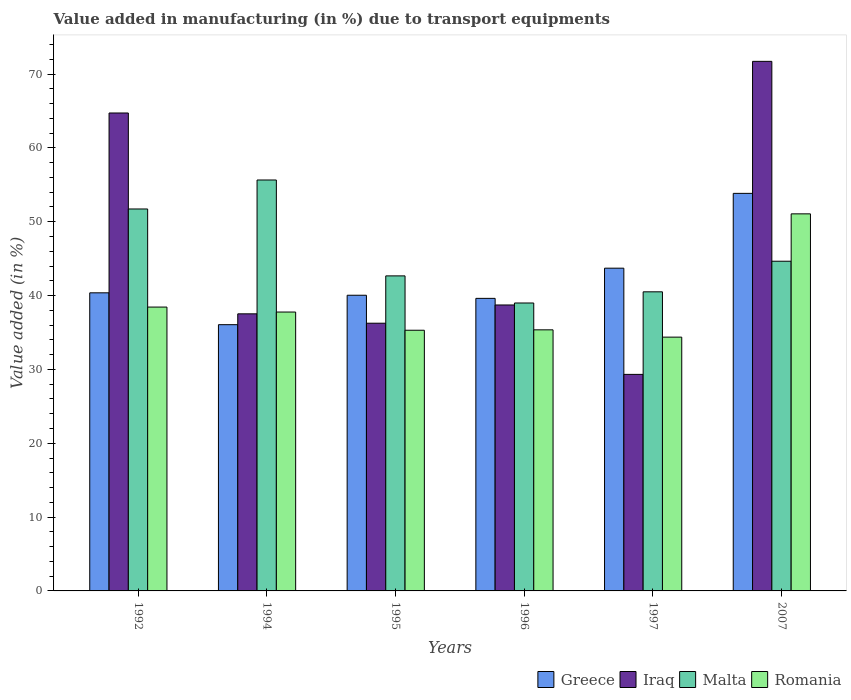How many different coloured bars are there?
Make the answer very short. 4. Are the number of bars per tick equal to the number of legend labels?
Make the answer very short. Yes. Are the number of bars on each tick of the X-axis equal?
Give a very brief answer. Yes. How many bars are there on the 6th tick from the right?
Your answer should be very brief. 4. What is the label of the 6th group of bars from the left?
Offer a very short reply. 2007. In how many cases, is the number of bars for a given year not equal to the number of legend labels?
Provide a succinct answer. 0. What is the percentage of value added in manufacturing due to transport equipments in Greece in 2007?
Offer a terse response. 53.84. Across all years, what is the maximum percentage of value added in manufacturing due to transport equipments in Romania?
Offer a very short reply. 51.06. Across all years, what is the minimum percentage of value added in manufacturing due to transport equipments in Romania?
Your answer should be compact. 34.37. In which year was the percentage of value added in manufacturing due to transport equipments in Romania maximum?
Offer a terse response. 2007. In which year was the percentage of value added in manufacturing due to transport equipments in Iraq minimum?
Offer a terse response. 1997. What is the total percentage of value added in manufacturing due to transport equipments in Malta in the graph?
Provide a succinct answer. 274.17. What is the difference between the percentage of value added in manufacturing due to transport equipments in Greece in 1995 and that in 1997?
Your answer should be very brief. -3.67. What is the difference between the percentage of value added in manufacturing due to transport equipments in Iraq in 2007 and the percentage of value added in manufacturing due to transport equipments in Malta in 1994?
Provide a succinct answer. 16.07. What is the average percentage of value added in manufacturing due to transport equipments in Romania per year?
Your response must be concise. 38.71. In the year 1995, what is the difference between the percentage of value added in manufacturing due to transport equipments in Romania and percentage of value added in manufacturing due to transport equipments in Iraq?
Your answer should be very brief. -0.95. In how many years, is the percentage of value added in manufacturing due to transport equipments in Malta greater than 46 %?
Your answer should be compact. 2. What is the ratio of the percentage of value added in manufacturing due to transport equipments in Iraq in 1992 to that in 2007?
Provide a short and direct response. 0.9. Is the percentage of value added in manufacturing due to transport equipments in Iraq in 1996 less than that in 2007?
Your answer should be compact. Yes. What is the difference between the highest and the second highest percentage of value added in manufacturing due to transport equipments in Iraq?
Provide a succinct answer. 6.99. What is the difference between the highest and the lowest percentage of value added in manufacturing due to transport equipments in Greece?
Offer a terse response. 17.78. In how many years, is the percentage of value added in manufacturing due to transport equipments in Romania greater than the average percentage of value added in manufacturing due to transport equipments in Romania taken over all years?
Give a very brief answer. 1. Is the sum of the percentage of value added in manufacturing due to transport equipments in Romania in 1996 and 1997 greater than the maximum percentage of value added in manufacturing due to transport equipments in Greece across all years?
Keep it short and to the point. Yes. What does the 1st bar from the left in 1994 represents?
Your answer should be very brief. Greece. What does the 2nd bar from the right in 1995 represents?
Offer a very short reply. Malta. Is it the case that in every year, the sum of the percentage of value added in manufacturing due to transport equipments in Romania and percentage of value added in manufacturing due to transport equipments in Greece is greater than the percentage of value added in manufacturing due to transport equipments in Iraq?
Keep it short and to the point. Yes. How many years are there in the graph?
Keep it short and to the point. 6. What is the difference between two consecutive major ticks on the Y-axis?
Keep it short and to the point. 10. Does the graph contain grids?
Offer a terse response. No. Where does the legend appear in the graph?
Make the answer very short. Bottom right. What is the title of the graph?
Provide a succinct answer. Value added in manufacturing (in %) due to transport equipments. Does "Grenada" appear as one of the legend labels in the graph?
Your answer should be compact. No. What is the label or title of the X-axis?
Provide a succinct answer. Years. What is the label or title of the Y-axis?
Offer a terse response. Value added (in %). What is the Value added (in %) of Greece in 1992?
Provide a short and direct response. 40.37. What is the Value added (in %) in Iraq in 1992?
Keep it short and to the point. 64.72. What is the Value added (in %) in Malta in 1992?
Your answer should be compact. 51.72. What is the Value added (in %) of Romania in 1992?
Make the answer very short. 38.44. What is the Value added (in %) of Greece in 1994?
Ensure brevity in your answer.  36.05. What is the Value added (in %) in Iraq in 1994?
Make the answer very short. 37.52. What is the Value added (in %) in Malta in 1994?
Ensure brevity in your answer.  55.65. What is the Value added (in %) of Romania in 1994?
Provide a short and direct response. 37.77. What is the Value added (in %) of Greece in 1995?
Ensure brevity in your answer.  40.04. What is the Value added (in %) in Iraq in 1995?
Make the answer very short. 36.25. What is the Value added (in %) of Malta in 1995?
Offer a terse response. 42.66. What is the Value added (in %) of Romania in 1995?
Your answer should be compact. 35.3. What is the Value added (in %) in Greece in 1996?
Provide a succinct answer. 39.62. What is the Value added (in %) in Iraq in 1996?
Offer a very short reply. 38.72. What is the Value added (in %) in Malta in 1996?
Your answer should be compact. 38.99. What is the Value added (in %) in Romania in 1996?
Give a very brief answer. 35.36. What is the Value added (in %) in Greece in 1997?
Your answer should be compact. 43.71. What is the Value added (in %) of Iraq in 1997?
Keep it short and to the point. 29.32. What is the Value added (in %) of Malta in 1997?
Provide a succinct answer. 40.5. What is the Value added (in %) in Romania in 1997?
Your answer should be very brief. 34.37. What is the Value added (in %) in Greece in 2007?
Offer a very short reply. 53.84. What is the Value added (in %) of Iraq in 2007?
Your answer should be compact. 71.71. What is the Value added (in %) of Malta in 2007?
Offer a very short reply. 44.65. What is the Value added (in %) in Romania in 2007?
Make the answer very short. 51.06. Across all years, what is the maximum Value added (in %) of Greece?
Provide a short and direct response. 53.84. Across all years, what is the maximum Value added (in %) in Iraq?
Provide a short and direct response. 71.71. Across all years, what is the maximum Value added (in %) of Malta?
Your answer should be compact. 55.65. Across all years, what is the maximum Value added (in %) of Romania?
Keep it short and to the point. 51.06. Across all years, what is the minimum Value added (in %) of Greece?
Ensure brevity in your answer.  36.05. Across all years, what is the minimum Value added (in %) of Iraq?
Provide a short and direct response. 29.32. Across all years, what is the minimum Value added (in %) of Malta?
Your answer should be compact. 38.99. Across all years, what is the minimum Value added (in %) of Romania?
Offer a terse response. 34.37. What is the total Value added (in %) of Greece in the graph?
Your answer should be very brief. 253.62. What is the total Value added (in %) of Iraq in the graph?
Offer a terse response. 278.26. What is the total Value added (in %) in Malta in the graph?
Make the answer very short. 274.17. What is the total Value added (in %) in Romania in the graph?
Provide a succinct answer. 232.29. What is the difference between the Value added (in %) in Greece in 1992 and that in 1994?
Offer a terse response. 4.31. What is the difference between the Value added (in %) in Iraq in 1992 and that in 1994?
Offer a terse response. 27.2. What is the difference between the Value added (in %) in Malta in 1992 and that in 1994?
Your response must be concise. -3.92. What is the difference between the Value added (in %) of Romania in 1992 and that in 1994?
Keep it short and to the point. 0.67. What is the difference between the Value added (in %) of Greece in 1992 and that in 1995?
Offer a very short reply. 0.33. What is the difference between the Value added (in %) of Iraq in 1992 and that in 1995?
Your answer should be very brief. 28.47. What is the difference between the Value added (in %) of Malta in 1992 and that in 1995?
Ensure brevity in your answer.  9.06. What is the difference between the Value added (in %) in Romania in 1992 and that in 1995?
Keep it short and to the point. 3.14. What is the difference between the Value added (in %) of Greece in 1992 and that in 1996?
Your answer should be very brief. 0.75. What is the difference between the Value added (in %) of Iraq in 1992 and that in 1996?
Give a very brief answer. 26. What is the difference between the Value added (in %) of Malta in 1992 and that in 1996?
Offer a very short reply. 12.73. What is the difference between the Value added (in %) of Romania in 1992 and that in 1996?
Keep it short and to the point. 3.08. What is the difference between the Value added (in %) in Greece in 1992 and that in 1997?
Provide a short and direct response. -3.34. What is the difference between the Value added (in %) of Iraq in 1992 and that in 1997?
Offer a terse response. 35.4. What is the difference between the Value added (in %) in Malta in 1992 and that in 1997?
Your answer should be very brief. 11.22. What is the difference between the Value added (in %) of Romania in 1992 and that in 1997?
Your response must be concise. 4.07. What is the difference between the Value added (in %) in Greece in 1992 and that in 2007?
Keep it short and to the point. -13.47. What is the difference between the Value added (in %) in Iraq in 1992 and that in 2007?
Your response must be concise. -6.99. What is the difference between the Value added (in %) in Malta in 1992 and that in 2007?
Keep it short and to the point. 7.07. What is the difference between the Value added (in %) of Romania in 1992 and that in 2007?
Keep it short and to the point. -12.62. What is the difference between the Value added (in %) of Greece in 1994 and that in 1995?
Keep it short and to the point. -3.99. What is the difference between the Value added (in %) in Iraq in 1994 and that in 1995?
Provide a succinct answer. 1.27. What is the difference between the Value added (in %) of Malta in 1994 and that in 1995?
Your answer should be compact. 12.98. What is the difference between the Value added (in %) in Romania in 1994 and that in 1995?
Offer a terse response. 2.46. What is the difference between the Value added (in %) of Greece in 1994 and that in 1996?
Your response must be concise. -3.56. What is the difference between the Value added (in %) in Iraq in 1994 and that in 1996?
Make the answer very short. -1.2. What is the difference between the Value added (in %) in Malta in 1994 and that in 1996?
Provide a succinct answer. 16.66. What is the difference between the Value added (in %) in Romania in 1994 and that in 1996?
Ensure brevity in your answer.  2.41. What is the difference between the Value added (in %) of Greece in 1994 and that in 1997?
Provide a short and direct response. -7.65. What is the difference between the Value added (in %) in Iraq in 1994 and that in 1997?
Offer a terse response. 8.2. What is the difference between the Value added (in %) in Malta in 1994 and that in 1997?
Offer a very short reply. 15.14. What is the difference between the Value added (in %) in Romania in 1994 and that in 1997?
Provide a succinct answer. 3.4. What is the difference between the Value added (in %) of Greece in 1994 and that in 2007?
Your answer should be very brief. -17.78. What is the difference between the Value added (in %) of Iraq in 1994 and that in 2007?
Provide a short and direct response. -34.19. What is the difference between the Value added (in %) of Malta in 1994 and that in 2007?
Your answer should be compact. 11. What is the difference between the Value added (in %) in Romania in 1994 and that in 2007?
Offer a terse response. -13.3. What is the difference between the Value added (in %) of Greece in 1995 and that in 1996?
Ensure brevity in your answer.  0.42. What is the difference between the Value added (in %) in Iraq in 1995 and that in 1996?
Offer a terse response. -2.47. What is the difference between the Value added (in %) of Malta in 1995 and that in 1996?
Keep it short and to the point. 3.67. What is the difference between the Value added (in %) of Romania in 1995 and that in 1996?
Offer a terse response. -0.06. What is the difference between the Value added (in %) of Greece in 1995 and that in 1997?
Offer a very short reply. -3.67. What is the difference between the Value added (in %) in Iraq in 1995 and that in 1997?
Ensure brevity in your answer.  6.93. What is the difference between the Value added (in %) in Malta in 1995 and that in 1997?
Give a very brief answer. 2.16. What is the difference between the Value added (in %) of Romania in 1995 and that in 1997?
Keep it short and to the point. 0.93. What is the difference between the Value added (in %) in Greece in 1995 and that in 2007?
Offer a very short reply. -13.8. What is the difference between the Value added (in %) in Iraq in 1995 and that in 2007?
Keep it short and to the point. -35.46. What is the difference between the Value added (in %) in Malta in 1995 and that in 2007?
Provide a short and direct response. -1.99. What is the difference between the Value added (in %) of Romania in 1995 and that in 2007?
Your answer should be compact. -15.76. What is the difference between the Value added (in %) in Greece in 1996 and that in 1997?
Ensure brevity in your answer.  -4.09. What is the difference between the Value added (in %) of Iraq in 1996 and that in 1997?
Provide a succinct answer. 9.4. What is the difference between the Value added (in %) of Malta in 1996 and that in 1997?
Provide a short and direct response. -1.51. What is the difference between the Value added (in %) of Greece in 1996 and that in 2007?
Offer a terse response. -14.22. What is the difference between the Value added (in %) of Iraq in 1996 and that in 2007?
Make the answer very short. -32.99. What is the difference between the Value added (in %) of Malta in 1996 and that in 2007?
Keep it short and to the point. -5.66. What is the difference between the Value added (in %) of Romania in 1996 and that in 2007?
Your answer should be compact. -15.71. What is the difference between the Value added (in %) of Greece in 1997 and that in 2007?
Ensure brevity in your answer.  -10.13. What is the difference between the Value added (in %) in Iraq in 1997 and that in 2007?
Your answer should be compact. -42.39. What is the difference between the Value added (in %) in Malta in 1997 and that in 2007?
Give a very brief answer. -4.14. What is the difference between the Value added (in %) of Romania in 1997 and that in 2007?
Make the answer very short. -16.7. What is the difference between the Value added (in %) in Greece in 1992 and the Value added (in %) in Iraq in 1994?
Provide a short and direct response. 2.84. What is the difference between the Value added (in %) in Greece in 1992 and the Value added (in %) in Malta in 1994?
Offer a very short reply. -15.28. What is the difference between the Value added (in %) of Greece in 1992 and the Value added (in %) of Romania in 1994?
Offer a very short reply. 2.6. What is the difference between the Value added (in %) in Iraq in 1992 and the Value added (in %) in Malta in 1994?
Give a very brief answer. 9.07. What is the difference between the Value added (in %) in Iraq in 1992 and the Value added (in %) in Romania in 1994?
Ensure brevity in your answer.  26.96. What is the difference between the Value added (in %) in Malta in 1992 and the Value added (in %) in Romania in 1994?
Provide a short and direct response. 13.96. What is the difference between the Value added (in %) of Greece in 1992 and the Value added (in %) of Iraq in 1995?
Offer a terse response. 4.11. What is the difference between the Value added (in %) in Greece in 1992 and the Value added (in %) in Malta in 1995?
Give a very brief answer. -2.29. What is the difference between the Value added (in %) of Greece in 1992 and the Value added (in %) of Romania in 1995?
Make the answer very short. 5.07. What is the difference between the Value added (in %) in Iraq in 1992 and the Value added (in %) in Malta in 1995?
Give a very brief answer. 22.06. What is the difference between the Value added (in %) in Iraq in 1992 and the Value added (in %) in Romania in 1995?
Make the answer very short. 29.42. What is the difference between the Value added (in %) in Malta in 1992 and the Value added (in %) in Romania in 1995?
Provide a succinct answer. 16.42. What is the difference between the Value added (in %) in Greece in 1992 and the Value added (in %) in Iraq in 1996?
Offer a very short reply. 1.64. What is the difference between the Value added (in %) of Greece in 1992 and the Value added (in %) of Malta in 1996?
Your answer should be very brief. 1.38. What is the difference between the Value added (in %) in Greece in 1992 and the Value added (in %) in Romania in 1996?
Provide a succinct answer. 5.01. What is the difference between the Value added (in %) of Iraq in 1992 and the Value added (in %) of Malta in 1996?
Your answer should be compact. 25.73. What is the difference between the Value added (in %) in Iraq in 1992 and the Value added (in %) in Romania in 1996?
Your answer should be compact. 29.37. What is the difference between the Value added (in %) of Malta in 1992 and the Value added (in %) of Romania in 1996?
Your answer should be compact. 16.37. What is the difference between the Value added (in %) of Greece in 1992 and the Value added (in %) of Iraq in 1997?
Your answer should be very brief. 11.05. What is the difference between the Value added (in %) of Greece in 1992 and the Value added (in %) of Malta in 1997?
Make the answer very short. -0.14. What is the difference between the Value added (in %) in Greece in 1992 and the Value added (in %) in Romania in 1997?
Provide a succinct answer. 6. What is the difference between the Value added (in %) in Iraq in 1992 and the Value added (in %) in Malta in 1997?
Your answer should be very brief. 24.22. What is the difference between the Value added (in %) in Iraq in 1992 and the Value added (in %) in Romania in 1997?
Keep it short and to the point. 30.35. What is the difference between the Value added (in %) in Malta in 1992 and the Value added (in %) in Romania in 1997?
Offer a very short reply. 17.35. What is the difference between the Value added (in %) in Greece in 1992 and the Value added (in %) in Iraq in 2007?
Make the answer very short. -31.35. What is the difference between the Value added (in %) in Greece in 1992 and the Value added (in %) in Malta in 2007?
Ensure brevity in your answer.  -4.28. What is the difference between the Value added (in %) of Greece in 1992 and the Value added (in %) of Romania in 2007?
Provide a short and direct response. -10.7. What is the difference between the Value added (in %) in Iraq in 1992 and the Value added (in %) in Malta in 2007?
Your answer should be compact. 20.07. What is the difference between the Value added (in %) of Iraq in 1992 and the Value added (in %) of Romania in 2007?
Keep it short and to the point. 13.66. What is the difference between the Value added (in %) in Malta in 1992 and the Value added (in %) in Romania in 2007?
Your answer should be compact. 0.66. What is the difference between the Value added (in %) of Greece in 1994 and the Value added (in %) of Iraq in 1995?
Your response must be concise. -0.2. What is the difference between the Value added (in %) in Greece in 1994 and the Value added (in %) in Malta in 1995?
Ensure brevity in your answer.  -6.61. What is the difference between the Value added (in %) in Greece in 1994 and the Value added (in %) in Romania in 1995?
Offer a terse response. 0.75. What is the difference between the Value added (in %) in Iraq in 1994 and the Value added (in %) in Malta in 1995?
Your answer should be compact. -5.14. What is the difference between the Value added (in %) of Iraq in 1994 and the Value added (in %) of Romania in 1995?
Your answer should be compact. 2.22. What is the difference between the Value added (in %) of Malta in 1994 and the Value added (in %) of Romania in 1995?
Provide a succinct answer. 20.35. What is the difference between the Value added (in %) of Greece in 1994 and the Value added (in %) of Iraq in 1996?
Offer a terse response. -2.67. What is the difference between the Value added (in %) in Greece in 1994 and the Value added (in %) in Malta in 1996?
Your answer should be compact. -2.94. What is the difference between the Value added (in %) of Greece in 1994 and the Value added (in %) of Romania in 1996?
Your response must be concise. 0.7. What is the difference between the Value added (in %) of Iraq in 1994 and the Value added (in %) of Malta in 1996?
Give a very brief answer. -1.47. What is the difference between the Value added (in %) of Iraq in 1994 and the Value added (in %) of Romania in 1996?
Offer a very short reply. 2.17. What is the difference between the Value added (in %) of Malta in 1994 and the Value added (in %) of Romania in 1996?
Keep it short and to the point. 20.29. What is the difference between the Value added (in %) of Greece in 1994 and the Value added (in %) of Iraq in 1997?
Your answer should be compact. 6.73. What is the difference between the Value added (in %) in Greece in 1994 and the Value added (in %) in Malta in 1997?
Offer a terse response. -4.45. What is the difference between the Value added (in %) in Greece in 1994 and the Value added (in %) in Romania in 1997?
Provide a short and direct response. 1.69. What is the difference between the Value added (in %) of Iraq in 1994 and the Value added (in %) of Malta in 1997?
Your answer should be compact. -2.98. What is the difference between the Value added (in %) of Iraq in 1994 and the Value added (in %) of Romania in 1997?
Offer a very short reply. 3.16. What is the difference between the Value added (in %) in Malta in 1994 and the Value added (in %) in Romania in 1997?
Provide a short and direct response. 21.28. What is the difference between the Value added (in %) of Greece in 1994 and the Value added (in %) of Iraq in 2007?
Ensure brevity in your answer.  -35.66. What is the difference between the Value added (in %) in Greece in 1994 and the Value added (in %) in Malta in 2007?
Provide a succinct answer. -8.59. What is the difference between the Value added (in %) in Greece in 1994 and the Value added (in %) in Romania in 2007?
Provide a short and direct response. -15.01. What is the difference between the Value added (in %) of Iraq in 1994 and the Value added (in %) of Malta in 2007?
Provide a succinct answer. -7.12. What is the difference between the Value added (in %) of Iraq in 1994 and the Value added (in %) of Romania in 2007?
Provide a short and direct response. -13.54. What is the difference between the Value added (in %) of Malta in 1994 and the Value added (in %) of Romania in 2007?
Your answer should be compact. 4.58. What is the difference between the Value added (in %) in Greece in 1995 and the Value added (in %) in Iraq in 1996?
Make the answer very short. 1.32. What is the difference between the Value added (in %) of Greece in 1995 and the Value added (in %) of Romania in 1996?
Your answer should be compact. 4.68. What is the difference between the Value added (in %) of Iraq in 1995 and the Value added (in %) of Malta in 1996?
Ensure brevity in your answer.  -2.74. What is the difference between the Value added (in %) in Iraq in 1995 and the Value added (in %) in Romania in 1996?
Provide a short and direct response. 0.9. What is the difference between the Value added (in %) of Malta in 1995 and the Value added (in %) of Romania in 1996?
Provide a succinct answer. 7.31. What is the difference between the Value added (in %) in Greece in 1995 and the Value added (in %) in Iraq in 1997?
Your answer should be very brief. 10.72. What is the difference between the Value added (in %) of Greece in 1995 and the Value added (in %) of Malta in 1997?
Make the answer very short. -0.46. What is the difference between the Value added (in %) in Greece in 1995 and the Value added (in %) in Romania in 1997?
Ensure brevity in your answer.  5.67. What is the difference between the Value added (in %) in Iraq in 1995 and the Value added (in %) in Malta in 1997?
Your answer should be compact. -4.25. What is the difference between the Value added (in %) in Iraq in 1995 and the Value added (in %) in Romania in 1997?
Provide a succinct answer. 1.89. What is the difference between the Value added (in %) in Malta in 1995 and the Value added (in %) in Romania in 1997?
Your answer should be very brief. 8.29. What is the difference between the Value added (in %) of Greece in 1995 and the Value added (in %) of Iraq in 2007?
Offer a very short reply. -31.67. What is the difference between the Value added (in %) in Greece in 1995 and the Value added (in %) in Malta in 2007?
Offer a very short reply. -4.61. What is the difference between the Value added (in %) in Greece in 1995 and the Value added (in %) in Romania in 2007?
Make the answer very short. -11.02. What is the difference between the Value added (in %) in Iraq in 1995 and the Value added (in %) in Malta in 2007?
Your response must be concise. -8.39. What is the difference between the Value added (in %) of Iraq in 1995 and the Value added (in %) of Romania in 2007?
Provide a short and direct response. -14.81. What is the difference between the Value added (in %) of Malta in 1995 and the Value added (in %) of Romania in 2007?
Offer a terse response. -8.4. What is the difference between the Value added (in %) in Greece in 1996 and the Value added (in %) in Iraq in 1997?
Your answer should be compact. 10.29. What is the difference between the Value added (in %) in Greece in 1996 and the Value added (in %) in Malta in 1997?
Give a very brief answer. -0.89. What is the difference between the Value added (in %) of Greece in 1996 and the Value added (in %) of Romania in 1997?
Give a very brief answer. 5.25. What is the difference between the Value added (in %) in Iraq in 1996 and the Value added (in %) in Malta in 1997?
Provide a succinct answer. -1.78. What is the difference between the Value added (in %) of Iraq in 1996 and the Value added (in %) of Romania in 1997?
Ensure brevity in your answer.  4.36. What is the difference between the Value added (in %) in Malta in 1996 and the Value added (in %) in Romania in 1997?
Your answer should be very brief. 4.62. What is the difference between the Value added (in %) in Greece in 1996 and the Value added (in %) in Iraq in 2007?
Offer a terse response. -32.1. What is the difference between the Value added (in %) in Greece in 1996 and the Value added (in %) in Malta in 2007?
Offer a terse response. -5.03. What is the difference between the Value added (in %) in Greece in 1996 and the Value added (in %) in Romania in 2007?
Keep it short and to the point. -11.45. What is the difference between the Value added (in %) of Iraq in 1996 and the Value added (in %) of Malta in 2007?
Your response must be concise. -5.92. What is the difference between the Value added (in %) of Iraq in 1996 and the Value added (in %) of Romania in 2007?
Offer a very short reply. -12.34. What is the difference between the Value added (in %) in Malta in 1996 and the Value added (in %) in Romania in 2007?
Your answer should be compact. -12.07. What is the difference between the Value added (in %) of Greece in 1997 and the Value added (in %) of Iraq in 2007?
Provide a short and direct response. -28.01. What is the difference between the Value added (in %) of Greece in 1997 and the Value added (in %) of Malta in 2007?
Keep it short and to the point. -0.94. What is the difference between the Value added (in %) in Greece in 1997 and the Value added (in %) in Romania in 2007?
Offer a terse response. -7.36. What is the difference between the Value added (in %) of Iraq in 1997 and the Value added (in %) of Malta in 2007?
Provide a short and direct response. -15.32. What is the difference between the Value added (in %) of Iraq in 1997 and the Value added (in %) of Romania in 2007?
Provide a short and direct response. -21.74. What is the difference between the Value added (in %) of Malta in 1997 and the Value added (in %) of Romania in 2007?
Provide a succinct answer. -10.56. What is the average Value added (in %) of Greece per year?
Keep it short and to the point. 42.27. What is the average Value added (in %) in Iraq per year?
Keep it short and to the point. 46.38. What is the average Value added (in %) of Malta per year?
Provide a succinct answer. 45.7. What is the average Value added (in %) of Romania per year?
Ensure brevity in your answer.  38.71. In the year 1992, what is the difference between the Value added (in %) of Greece and Value added (in %) of Iraq?
Ensure brevity in your answer.  -24.35. In the year 1992, what is the difference between the Value added (in %) of Greece and Value added (in %) of Malta?
Your answer should be compact. -11.35. In the year 1992, what is the difference between the Value added (in %) in Greece and Value added (in %) in Romania?
Give a very brief answer. 1.93. In the year 1992, what is the difference between the Value added (in %) in Iraq and Value added (in %) in Malta?
Your response must be concise. 13. In the year 1992, what is the difference between the Value added (in %) of Iraq and Value added (in %) of Romania?
Offer a terse response. 26.28. In the year 1992, what is the difference between the Value added (in %) in Malta and Value added (in %) in Romania?
Your response must be concise. 13.28. In the year 1994, what is the difference between the Value added (in %) of Greece and Value added (in %) of Iraq?
Make the answer very short. -1.47. In the year 1994, what is the difference between the Value added (in %) of Greece and Value added (in %) of Malta?
Provide a short and direct response. -19.59. In the year 1994, what is the difference between the Value added (in %) of Greece and Value added (in %) of Romania?
Keep it short and to the point. -1.71. In the year 1994, what is the difference between the Value added (in %) in Iraq and Value added (in %) in Malta?
Ensure brevity in your answer.  -18.12. In the year 1994, what is the difference between the Value added (in %) of Iraq and Value added (in %) of Romania?
Offer a terse response. -0.24. In the year 1994, what is the difference between the Value added (in %) in Malta and Value added (in %) in Romania?
Your answer should be very brief. 17.88. In the year 1995, what is the difference between the Value added (in %) in Greece and Value added (in %) in Iraq?
Provide a short and direct response. 3.79. In the year 1995, what is the difference between the Value added (in %) of Greece and Value added (in %) of Malta?
Offer a terse response. -2.62. In the year 1995, what is the difference between the Value added (in %) of Greece and Value added (in %) of Romania?
Give a very brief answer. 4.74. In the year 1995, what is the difference between the Value added (in %) in Iraq and Value added (in %) in Malta?
Your answer should be compact. -6.41. In the year 1995, what is the difference between the Value added (in %) in Iraq and Value added (in %) in Romania?
Give a very brief answer. 0.95. In the year 1995, what is the difference between the Value added (in %) of Malta and Value added (in %) of Romania?
Offer a very short reply. 7.36. In the year 1996, what is the difference between the Value added (in %) in Greece and Value added (in %) in Iraq?
Offer a terse response. 0.89. In the year 1996, what is the difference between the Value added (in %) in Greece and Value added (in %) in Malta?
Provide a succinct answer. 0.63. In the year 1996, what is the difference between the Value added (in %) of Greece and Value added (in %) of Romania?
Provide a short and direct response. 4.26. In the year 1996, what is the difference between the Value added (in %) in Iraq and Value added (in %) in Malta?
Offer a terse response. -0.27. In the year 1996, what is the difference between the Value added (in %) of Iraq and Value added (in %) of Romania?
Offer a very short reply. 3.37. In the year 1996, what is the difference between the Value added (in %) in Malta and Value added (in %) in Romania?
Give a very brief answer. 3.63. In the year 1997, what is the difference between the Value added (in %) in Greece and Value added (in %) in Iraq?
Your answer should be very brief. 14.38. In the year 1997, what is the difference between the Value added (in %) of Greece and Value added (in %) of Malta?
Your answer should be very brief. 3.2. In the year 1997, what is the difference between the Value added (in %) of Greece and Value added (in %) of Romania?
Your response must be concise. 9.34. In the year 1997, what is the difference between the Value added (in %) of Iraq and Value added (in %) of Malta?
Give a very brief answer. -11.18. In the year 1997, what is the difference between the Value added (in %) in Iraq and Value added (in %) in Romania?
Offer a very short reply. -5.04. In the year 1997, what is the difference between the Value added (in %) in Malta and Value added (in %) in Romania?
Offer a very short reply. 6.14. In the year 2007, what is the difference between the Value added (in %) of Greece and Value added (in %) of Iraq?
Offer a terse response. -17.88. In the year 2007, what is the difference between the Value added (in %) of Greece and Value added (in %) of Malta?
Give a very brief answer. 9.19. In the year 2007, what is the difference between the Value added (in %) of Greece and Value added (in %) of Romania?
Your answer should be very brief. 2.77. In the year 2007, what is the difference between the Value added (in %) in Iraq and Value added (in %) in Malta?
Provide a succinct answer. 27.07. In the year 2007, what is the difference between the Value added (in %) in Iraq and Value added (in %) in Romania?
Offer a terse response. 20.65. In the year 2007, what is the difference between the Value added (in %) in Malta and Value added (in %) in Romania?
Provide a short and direct response. -6.42. What is the ratio of the Value added (in %) of Greece in 1992 to that in 1994?
Your answer should be very brief. 1.12. What is the ratio of the Value added (in %) in Iraq in 1992 to that in 1994?
Give a very brief answer. 1.72. What is the ratio of the Value added (in %) of Malta in 1992 to that in 1994?
Ensure brevity in your answer.  0.93. What is the ratio of the Value added (in %) in Romania in 1992 to that in 1994?
Your answer should be compact. 1.02. What is the ratio of the Value added (in %) of Greece in 1992 to that in 1995?
Your answer should be compact. 1.01. What is the ratio of the Value added (in %) in Iraq in 1992 to that in 1995?
Provide a succinct answer. 1.79. What is the ratio of the Value added (in %) in Malta in 1992 to that in 1995?
Give a very brief answer. 1.21. What is the ratio of the Value added (in %) in Romania in 1992 to that in 1995?
Your answer should be very brief. 1.09. What is the ratio of the Value added (in %) in Greece in 1992 to that in 1996?
Your response must be concise. 1.02. What is the ratio of the Value added (in %) of Iraq in 1992 to that in 1996?
Your answer should be compact. 1.67. What is the ratio of the Value added (in %) in Malta in 1992 to that in 1996?
Ensure brevity in your answer.  1.33. What is the ratio of the Value added (in %) in Romania in 1992 to that in 1996?
Offer a very short reply. 1.09. What is the ratio of the Value added (in %) of Greece in 1992 to that in 1997?
Keep it short and to the point. 0.92. What is the ratio of the Value added (in %) in Iraq in 1992 to that in 1997?
Make the answer very short. 2.21. What is the ratio of the Value added (in %) in Malta in 1992 to that in 1997?
Your answer should be compact. 1.28. What is the ratio of the Value added (in %) of Romania in 1992 to that in 1997?
Provide a succinct answer. 1.12. What is the ratio of the Value added (in %) of Greece in 1992 to that in 2007?
Your response must be concise. 0.75. What is the ratio of the Value added (in %) in Iraq in 1992 to that in 2007?
Keep it short and to the point. 0.9. What is the ratio of the Value added (in %) in Malta in 1992 to that in 2007?
Provide a succinct answer. 1.16. What is the ratio of the Value added (in %) in Romania in 1992 to that in 2007?
Your response must be concise. 0.75. What is the ratio of the Value added (in %) in Greece in 1994 to that in 1995?
Give a very brief answer. 0.9. What is the ratio of the Value added (in %) in Iraq in 1994 to that in 1995?
Provide a short and direct response. 1.03. What is the ratio of the Value added (in %) of Malta in 1994 to that in 1995?
Make the answer very short. 1.3. What is the ratio of the Value added (in %) in Romania in 1994 to that in 1995?
Offer a terse response. 1.07. What is the ratio of the Value added (in %) of Greece in 1994 to that in 1996?
Provide a succinct answer. 0.91. What is the ratio of the Value added (in %) of Iraq in 1994 to that in 1996?
Give a very brief answer. 0.97. What is the ratio of the Value added (in %) in Malta in 1994 to that in 1996?
Keep it short and to the point. 1.43. What is the ratio of the Value added (in %) of Romania in 1994 to that in 1996?
Keep it short and to the point. 1.07. What is the ratio of the Value added (in %) in Greece in 1994 to that in 1997?
Keep it short and to the point. 0.82. What is the ratio of the Value added (in %) in Iraq in 1994 to that in 1997?
Your response must be concise. 1.28. What is the ratio of the Value added (in %) in Malta in 1994 to that in 1997?
Offer a very short reply. 1.37. What is the ratio of the Value added (in %) in Romania in 1994 to that in 1997?
Your answer should be very brief. 1.1. What is the ratio of the Value added (in %) in Greece in 1994 to that in 2007?
Provide a short and direct response. 0.67. What is the ratio of the Value added (in %) in Iraq in 1994 to that in 2007?
Ensure brevity in your answer.  0.52. What is the ratio of the Value added (in %) of Malta in 1994 to that in 2007?
Provide a short and direct response. 1.25. What is the ratio of the Value added (in %) of Romania in 1994 to that in 2007?
Provide a short and direct response. 0.74. What is the ratio of the Value added (in %) in Greece in 1995 to that in 1996?
Ensure brevity in your answer.  1.01. What is the ratio of the Value added (in %) of Iraq in 1995 to that in 1996?
Your answer should be compact. 0.94. What is the ratio of the Value added (in %) in Malta in 1995 to that in 1996?
Offer a very short reply. 1.09. What is the ratio of the Value added (in %) of Romania in 1995 to that in 1996?
Your response must be concise. 1. What is the ratio of the Value added (in %) of Greece in 1995 to that in 1997?
Ensure brevity in your answer.  0.92. What is the ratio of the Value added (in %) of Iraq in 1995 to that in 1997?
Your answer should be compact. 1.24. What is the ratio of the Value added (in %) of Malta in 1995 to that in 1997?
Your response must be concise. 1.05. What is the ratio of the Value added (in %) of Romania in 1995 to that in 1997?
Your response must be concise. 1.03. What is the ratio of the Value added (in %) in Greece in 1995 to that in 2007?
Give a very brief answer. 0.74. What is the ratio of the Value added (in %) of Iraq in 1995 to that in 2007?
Give a very brief answer. 0.51. What is the ratio of the Value added (in %) in Malta in 1995 to that in 2007?
Offer a terse response. 0.96. What is the ratio of the Value added (in %) in Romania in 1995 to that in 2007?
Your answer should be compact. 0.69. What is the ratio of the Value added (in %) in Greece in 1996 to that in 1997?
Your answer should be very brief. 0.91. What is the ratio of the Value added (in %) in Iraq in 1996 to that in 1997?
Your answer should be very brief. 1.32. What is the ratio of the Value added (in %) of Malta in 1996 to that in 1997?
Your response must be concise. 0.96. What is the ratio of the Value added (in %) of Romania in 1996 to that in 1997?
Provide a succinct answer. 1.03. What is the ratio of the Value added (in %) in Greece in 1996 to that in 2007?
Ensure brevity in your answer.  0.74. What is the ratio of the Value added (in %) of Iraq in 1996 to that in 2007?
Ensure brevity in your answer.  0.54. What is the ratio of the Value added (in %) in Malta in 1996 to that in 2007?
Ensure brevity in your answer.  0.87. What is the ratio of the Value added (in %) of Romania in 1996 to that in 2007?
Your answer should be very brief. 0.69. What is the ratio of the Value added (in %) of Greece in 1997 to that in 2007?
Offer a very short reply. 0.81. What is the ratio of the Value added (in %) in Iraq in 1997 to that in 2007?
Keep it short and to the point. 0.41. What is the ratio of the Value added (in %) of Malta in 1997 to that in 2007?
Provide a short and direct response. 0.91. What is the ratio of the Value added (in %) in Romania in 1997 to that in 2007?
Provide a succinct answer. 0.67. What is the difference between the highest and the second highest Value added (in %) of Greece?
Make the answer very short. 10.13. What is the difference between the highest and the second highest Value added (in %) of Iraq?
Offer a very short reply. 6.99. What is the difference between the highest and the second highest Value added (in %) in Malta?
Give a very brief answer. 3.92. What is the difference between the highest and the second highest Value added (in %) in Romania?
Ensure brevity in your answer.  12.62. What is the difference between the highest and the lowest Value added (in %) in Greece?
Offer a terse response. 17.78. What is the difference between the highest and the lowest Value added (in %) of Iraq?
Offer a very short reply. 42.39. What is the difference between the highest and the lowest Value added (in %) of Malta?
Your answer should be compact. 16.66. What is the difference between the highest and the lowest Value added (in %) in Romania?
Provide a succinct answer. 16.7. 